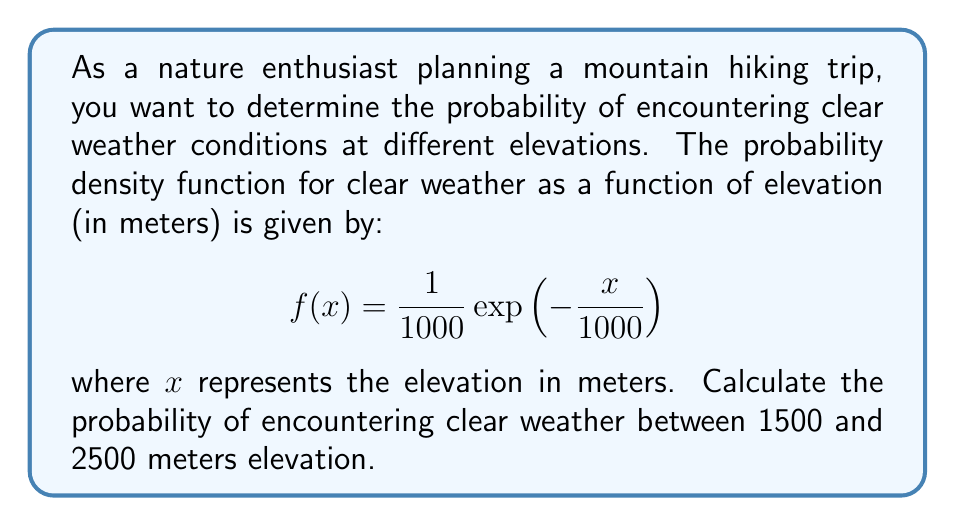What is the answer to this math problem? To solve this problem, we need to integrate the probability density function between the given elevation range. The steps are as follows:

1) The probability of encountering clear weather between 1500 and 2500 meters is given by the definite integral:

   $$P(1500 \leq x \leq 2500) = \int_{1500}^{2500} f(x) dx$$

2) Substituting the given probability density function:

   $$P(1500 \leq x \leq 2500) = \int_{1500}^{2500} \frac{1}{1000}\exp\left(-\frac{x}{1000}\right) dx$$

3) To evaluate this integral, we can use the substitution method. Let $u = -\frac{x}{1000}$, then $du = -\frac{1}{1000}dx$, or $dx = -1000du$. The limits of integration change to:
   
   When $x = 1500$, $u = -1.5$
   When $x = 2500$, $u = -2.5$

4) Rewriting the integral:

   $$P(1500 \leq x \leq 2500) = \int_{-2.5}^{-1.5} \exp(u) (-du) = \int_{-1.5}^{-2.5} \exp(u) du$$

5) Evaluating the integral:

   $$P(1500 \leq x \leq 2500) = [-\exp(u)]_{-1.5}^{-2.5} = -\exp(-2.5) + \exp(-1.5)$$

6) Calculate the final result:

   $$P(1500 \leq x \leq 2500) = -0.0821 + 0.2231 = 0.1410$$
Answer: The probability of encountering clear weather between 1500 and 2500 meters elevation is approximately 0.1410 or 14.10%. 